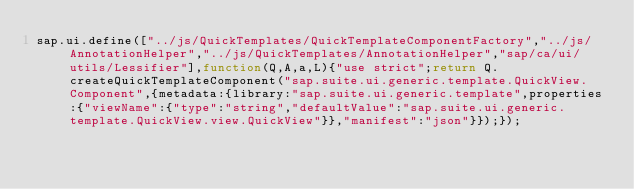Convert code to text. <code><loc_0><loc_0><loc_500><loc_500><_JavaScript_>sap.ui.define(["../js/QuickTemplates/QuickTemplateComponentFactory","../js/AnnotationHelper","../js/QuickTemplates/AnnotationHelper","sap/ca/ui/utils/Lessifier"],function(Q,A,a,L){"use strict";return Q.createQuickTemplateComponent("sap.suite.ui.generic.template.QuickView.Component",{metadata:{library:"sap.suite.ui.generic.template",properties:{"viewName":{"type":"string","defaultValue":"sap.suite.ui.generic.template.QuickView.view.QuickView"}},"manifest":"json"}});});
</code> 